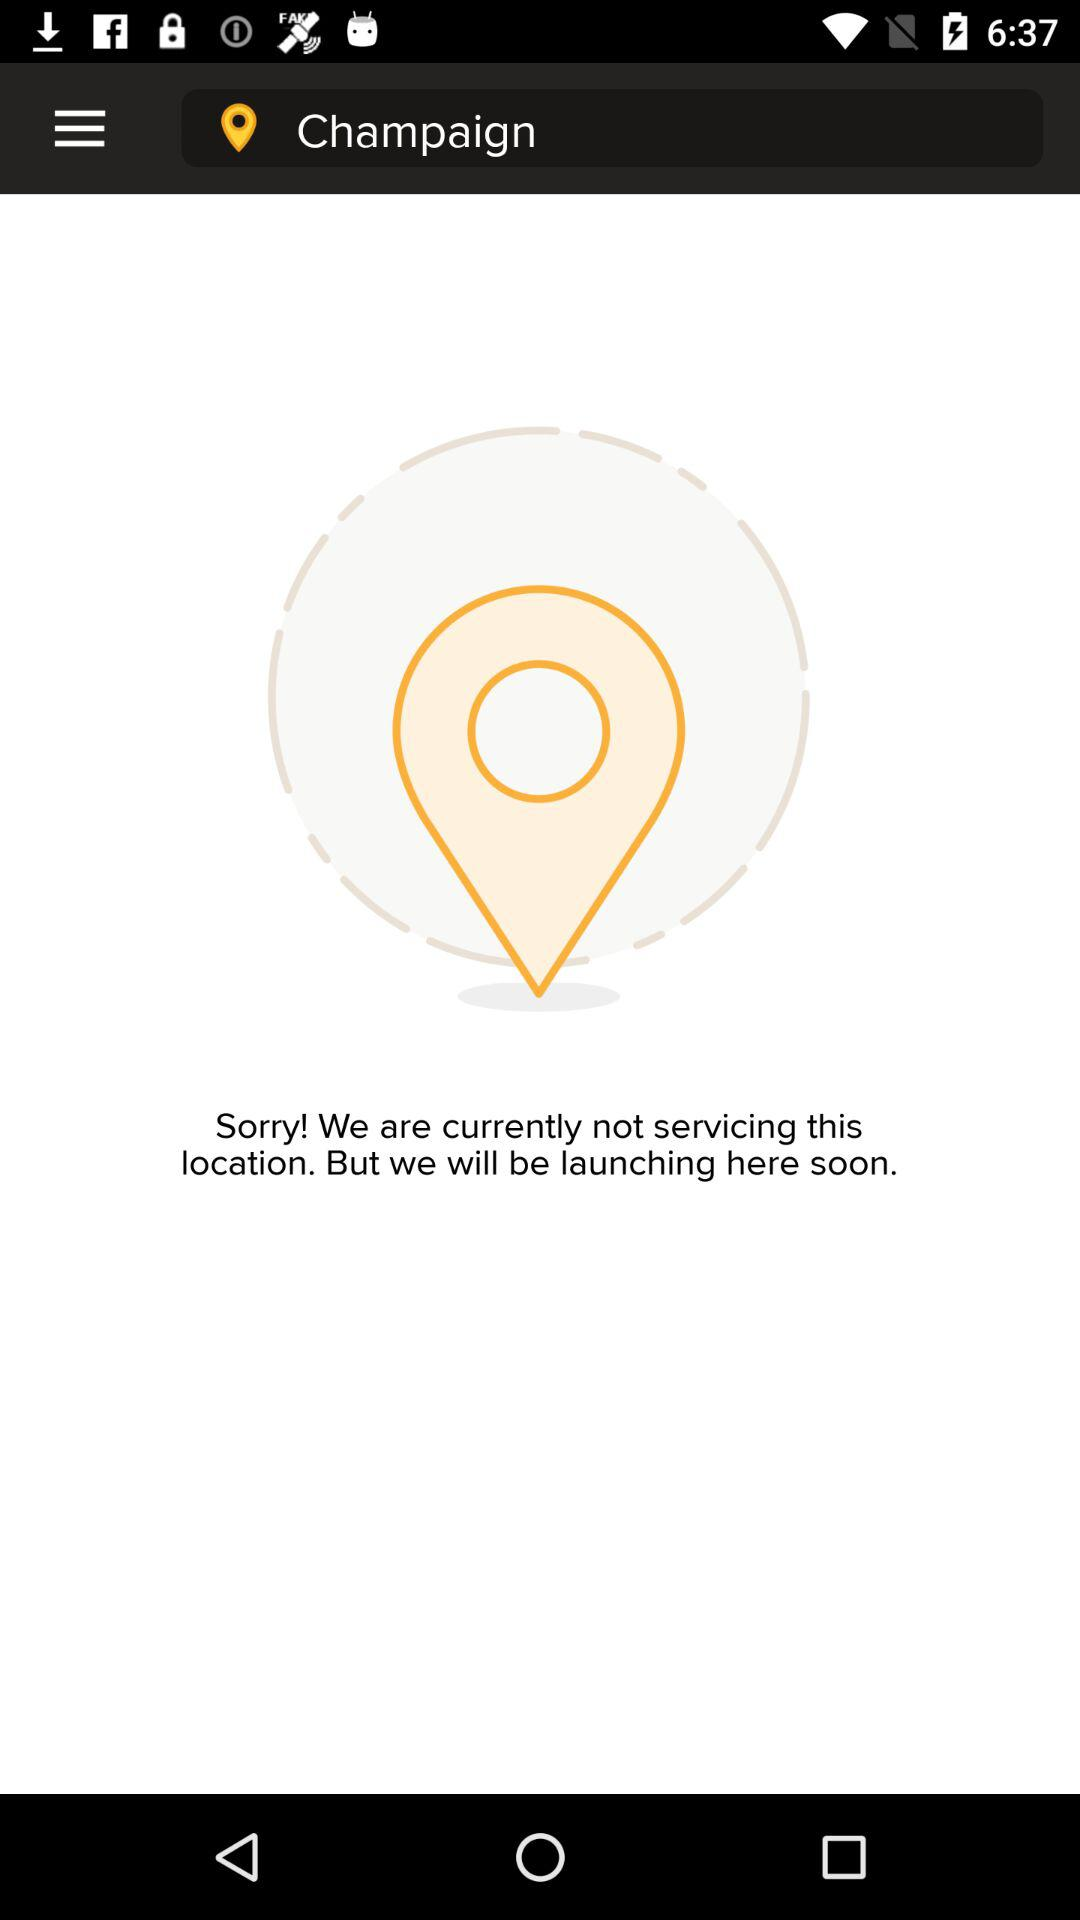What is the mentioned location? The mentioned location is Champaign. 